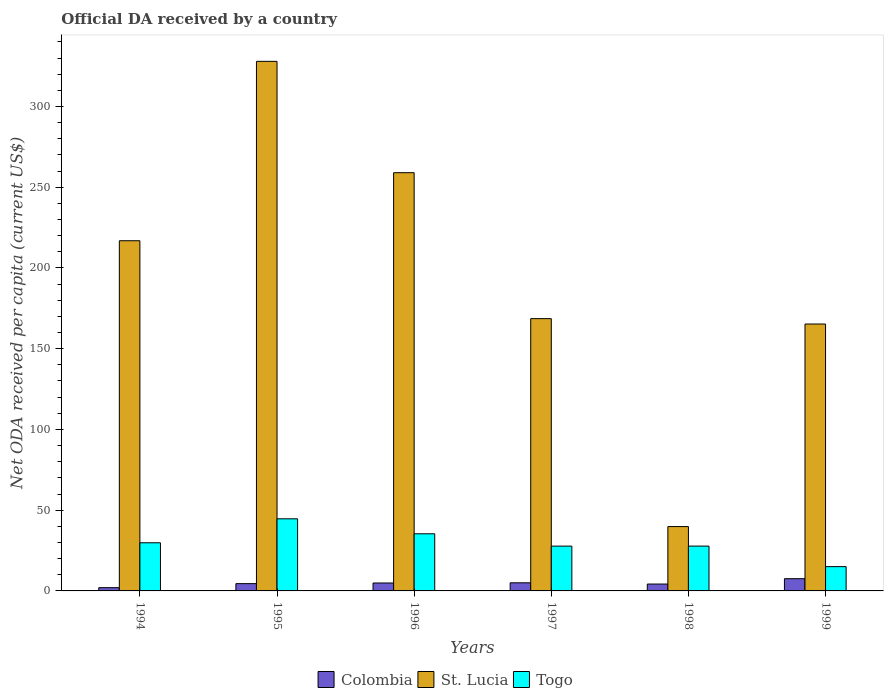Are the number of bars on each tick of the X-axis equal?
Your answer should be very brief. Yes. How many bars are there on the 5th tick from the left?
Your response must be concise. 3. How many bars are there on the 5th tick from the right?
Offer a terse response. 3. In how many cases, is the number of bars for a given year not equal to the number of legend labels?
Offer a very short reply. 0. What is the ODA received in in St. Lucia in 1995?
Your answer should be compact. 327.94. Across all years, what is the maximum ODA received in in Togo?
Give a very brief answer. 44.66. Across all years, what is the minimum ODA received in in Togo?
Ensure brevity in your answer.  15.04. In which year was the ODA received in in St. Lucia minimum?
Your response must be concise. 1998. What is the total ODA received in in St. Lucia in the graph?
Your response must be concise. 1177.52. What is the difference between the ODA received in in St. Lucia in 1994 and that in 1998?
Offer a very short reply. 177. What is the difference between the ODA received in in Colombia in 1997 and the ODA received in in St. Lucia in 1994?
Offer a very short reply. -211.83. What is the average ODA received in in Togo per year?
Provide a short and direct response. 30.06. In the year 1999, what is the difference between the ODA received in in Colombia and ODA received in in Togo?
Your response must be concise. -7.47. In how many years, is the ODA received in in Togo greater than 30 US$?
Keep it short and to the point. 2. What is the ratio of the ODA received in in Togo in 1994 to that in 1998?
Give a very brief answer. 1.07. Is the ODA received in in Colombia in 1996 less than that in 1999?
Ensure brevity in your answer.  Yes. Is the difference between the ODA received in in Colombia in 1995 and 1997 greater than the difference between the ODA received in in Togo in 1995 and 1997?
Keep it short and to the point. No. What is the difference between the highest and the second highest ODA received in in Colombia?
Your answer should be very brief. 2.55. What is the difference between the highest and the lowest ODA received in in Togo?
Your answer should be compact. 29.62. Is the sum of the ODA received in in St. Lucia in 1998 and 1999 greater than the maximum ODA received in in Colombia across all years?
Offer a very short reply. Yes. What does the 2nd bar from the left in 1997 represents?
Your answer should be very brief. St. Lucia. What does the 1st bar from the right in 1995 represents?
Give a very brief answer. Togo. Is it the case that in every year, the sum of the ODA received in in Togo and ODA received in in St. Lucia is greater than the ODA received in in Colombia?
Offer a terse response. Yes. How many years are there in the graph?
Give a very brief answer. 6. Are the values on the major ticks of Y-axis written in scientific E-notation?
Offer a very short reply. No. Does the graph contain grids?
Your answer should be compact. No. Where does the legend appear in the graph?
Provide a short and direct response. Bottom center. What is the title of the graph?
Your answer should be compact. Official DA received by a country. Does "Other small states" appear as one of the legend labels in the graph?
Offer a very short reply. No. What is the label or title of the Y-axis?
Keep it short and to the point. Net ODA received per capita (current US$). What is the Net ODA received per capita (current US$) in Colombia in 1994?
Give a very brief answer. 2.02. What is the Net ODA received per capita (current US$) of St. Lucia in 1994?
Make the answer very short. 216.85. What is the Net ODA received per capita (current US$) of Togo in 1994?
Your answer should be very brief. 29.82. What is the Net ODA received per capita (current US$) of Colombia in 1995?
Keep it short and to the point. 4.51. What is the Net ODA received per capita (current US$) in St. Lucia in 1995?
Provide a short and direct response. 327.94. What is the Net ODA received per capita (current US$) of Togo in 1995?
Provide a succinct answer. 44.66. What is the Net ODA received per capita (current US$) of Colombia in 1996?
Offer a terse response. 4.91. What is the Net ODA received per capita (current US$) of St. Lucia in 1996?
Provide a succinct answer. 258.99. What is the Net ODA received per capita (current US$) of Togo in 1996?
Your response must be concise. 35.37. What is the Net ODA received per capita (current US$) of Colombia in 1997?
Keep it short and to the point. 5.02. What is the Net ODA received per capita (current US$) in St. Lucia in 1997?
Offer a terse response. 168.62. What is the Net ODA received per capita (current US$) of Togo in 1997?
Offer a very short reply. 27.74. What is the Net ODA received per capita (current US$) of Colombia in 1998?
Provide a short and direct response. 4.26. What is the Net ODA received per capita (current US$) in St. Lucia in 1998?
Keep it short and to the point. 39.85. What is the Net ODA received per capita (current US$) of Togo in 1998?
Give a very brief answer. 27.75. What is the Net ODA received per capita (current US$) in Colombia in 1999?
Offer a very short reply. 7.57. What is the Net ODA received per capita (current US$) in St. Lucia in 1999?
Your answer should be compact. 165.28. What is the Net ODA received per capita (current US$) of Togo in 1999?
Keep it short and to the point. 15.04. Across all years, what is the maximum Net ODA received per capita (current US$) in Colombia?
Offer a very short reply. 7.57. Across all years, what is the maximum Net ODA received per capita (current US$) in St. Lucia?
Your answer should be compact. 327.94. Across all years, what is the maximum Net ODA received per capita (current US$) of Togo?
Offer a very short reply. 44.66. Across all years, what is the minimum Net ODA received per capita (current US$) in Colombia?
Make the answer very short. 2.02. Across all years, what is the minimum Net ODA received per capita (current US$) of St. Lucia?
Offer a very short reply. 39.85. Across all years, what is the minimum Net ODA received per capita (current US$) in Togo?
Your answer should be very brief. 15.04. What is the total Net ODA received per capita (current US$) of Colombia in the graph?
Make the answer very short. 28.3. What is the total Net ODA received per capita (current US$) of St. Lucia in the graph?
Make the answer very short. 1177.52. What is the total Net ODA received per capita (current US$) of Togo in the graph?
Provide a short and direct response. 180.39. What is the difference between the Net ODA received per capita (current US$) in Colombia in 1994 and that in 1995?
Your answer should be very brief. -2.49. What is the difference between the Net ODA received per capita (current US$) in St. Lucia in 1994 and that in 1995?
Provide a short and direct response. -111.09. What is the difference between the Net ODA received per capita (current US$) in Togo in 1994 and that in 1995?
Make the answer very short. -14.85. What is the difference between the Net ODA received per capita (current US$) in Colombia in 1994 and that in 1996?
Offer a very short reply. -2.89. What is the difference between the Net ODA received per capita (current US$) of St. Lucia in 1994 and that in 1996?
Offer a very short reply. -42.14. What is the difference between the Net ODA received per capita (current US$) in Togo in 1994 and that in 1996?
Offer a very short reply. -5.56. What is the difference between the Net ODA received per capita (current US$) of Colombia in 1994 and that in 1997?
Give a very brief answer. -3. What is the difference between the Net ODA received per capita (current US$) in St. Lucia in 1994 and that in 1997?
Your answer should be very brief. 48.23. What is the difference between the Net ODA received per capita (current US$) of Togo in 1994 and that in 1997?
Offer a terse response. 2.07. What is the difference between the Net ODA received per capita (current US$) in Colombia in 1994 and that in 1998?
Your response must be concise. -2.24. What is the difference between the Net ODA received per capita (current US$) of St. Lucia in 1994 and that in 1998?
Offer a terse response. 177. What is the difference between the Net ODA received per capita (current US$) in Togo in 1994 and that in 1998?
Ensure brevity in your answer.  2.06. What is the difference between the Net ODA received per capita (current US$) in Colombia in 1994 and that in 1999?
Keep it short and to the point. -5.55. What is the difference between the Net ODA received per capita (current US$) in St. Lucia in 1994 and that in 1999?
Provide a succinct answer. 51.57. What is the difference between the Net ODA received per capita (current US$) of Togo in 1994 and that in 1999?
Give a very brief answer. 14.77. What is the difference between the Net ODA received per capita (current US$) of Colombia in 1995 and that in 1996?
Make the answer very short. -0.4. What is the difference between the Net ODA received per capita (current US$) in St. Lucia in 1995 and that in 1996?
Your response must be concise. 68.95. What is the difference between the Net ODA received per capita (current US$) in Togo in 1995 and that in 1996?
Your response must be concise. 9.29. What is the difference between the Net ODA received per capita (current US$) of Colombia in 1995 and that in 1997?
Keep it short and to the point. -0.51. What is the difference between the Net ODA received per capita (current US$) of St. Lucia in 1995 and that in 1997?
Your response must be concise. 159.32. What is the difference between the Net ODA received per capita (current US$) in Togo in 1995 and that in 1997?
Your response must be concise. 16.92. What is the difference between the Net ODA received per capita (current US$) of Colombia in 1995 and that in 1998?
Offer a terse response. 0.25. What is the difference between the Net ODA received per capita (current US$) in St. Lucia in 1995 and that in 1998?
Provide a succinct answer. 288.09. What is the difference between the Net ODA received per capita (current US$) in Togo in 1995 and that in 1998?
Your answer should be very brief. 16.91. What is the difference between the Net ODA received per capita (current US$) of Colombia in 1995 and that in 1999?
Provide a succinct answer. -3.06. What is the difference between the Net ODA received per capita (current US$) of St. Lucia in 1995 and that in 1999?
Offer a terse response. 162.66. What is the difference between the Net ODA received per capita (current US$) of Togo in 1995 and that in 1999?
Offer a very short reply. 29.62. What is the difference between the Net ODA received per capita (current US$) in Colombia in 1996 and that in 1997?
Ensure brevity in your answer.  -0.11. What is the difference between the Net ODA received per capita (current US$) in St. Lucia in 1996 and that in 1997?
Keep it short and to the point. 90.38. What is the difference between the Net ODA received per capita (current US$) of Togo in 1996 and that in 1997?
Give a very brief answer. 7.63. What is the difference between the Net ODA received per capita (current US$) of Colombia in 1996 and that in 1998?
Make the answer very short. 0.65. What is the difference between the Net ODA received per capita (current US$) of St. Lucia in 1996 and that in 1998?
Give a very brief answer. 219.14. What is the difference between the Net ODA received per capita (current US$) in Togo in 1996 and that in 1998?
Offer a very short reply. 7.62. What is the difference between the Net ODA received per capita (current US$) in Colombia in 1996 and that in 1999?
Provide a succinct answer. -2.66. What is the difference between the Net ODA received per capita (current US$) of St. Lucia in 1996 and that in 1999?
Your answer should be very brief. 93.72. What is the difference between the Net ODA received per capita (current US$) of Togo in 1996 and that in 1999?
Ensure brevity in your answer.  20.33. What is the difference between the Net ODA received per capita (current US$) in Colombia in 1997 and that in 1998?
Offer a terse response. 0.76. What is the difference between the Net ODA received per capita (current US$) in St. Lucia in 1997 and that in 1998?
Ensure brevity in your answer.  128.76. What is the difference between the Net ODA received per capita (current US$) of Togo in 1997 and that in 1998?
Ensure brevity in your answer.  -0.01. What is the difference between the Net ODA received per capita (current US$) of Colombia in 1997 and that in 1999?
Provide a short and direct response. -2.55. What is the difference between the Net ODA received per capita (current US$) in St. Lucia in 1997 and that in 1999?
Your answer should be very brief. 3.34. What is the difference between the Net ODA received per capita (current US$) of Togo in 1997 and that in 1999?
Give a very brief answer. 12.7. What is the difference between the Net ODA received per capita (current US$) in Colombia in 1998 and that in 1999?
Provide a short and direct response. -3.32. What is the difference between the Net ODA received per capita (current US$) in St. Lucia in 1998 and that in 1999?
Offer a very short reply. -125.42. What is the difference between the Net ODA received per capita (current US$) of Togo in 1998 and that in 1999?
Your answer should be compact. 12.71. What is the difference between the Net ODA received per capita (current US$) in Colombia in 1994 and the Net ODA received per capita (current US$) in St. Lucia in 1995?
Keep it short and to the point. -325.92. What is the difference between the Net ODA received per capita (current US$) in Colombia in 1994 and the Net ODA received per capita (current US$) in Togo in 1995?
Keep it short and to the point. -42.64. What is the difference between the Net ODA received per capita (current US$) of St. Lucia in 1994 and the Net ODA received per capita (current US$) of Togo in 1995?
Your answer should be very brief. 172.19. What is the difference between the Net ODA received per capita (current US$) of Colombia in 1994 and the Net ODA received per capita (current US$) of St. Lucia in 1996?
Offer a terse response. -256.97. What is the difference between the Net ODA received per capita (current US$) of Colombia in 1994 and the Net ODA received per capita (current US$) of Togo in 1996?
Offer a terse response. -33.36. What is the difference between the Net ODA received per capita (current US$) in St. Lucia in 1994 and the Net ODA received per capita (current US$) in Togo in 1996?
Your response must be concise. 181.47. What is the difference between the Net ODA received per capita (current US$) of Colombia in 1994 and the Net ODA received per capita (current US$) of St. Lucia in 1997?
Keep it short and to the point. -166.6. What is the difference between the Net ODA received per capita (current US$) of Colombia in 1994 and the Net ODA received per capita (current US$) of Togo in 1997?
Offer a terse response. -25.72. What is the difference between the Net ODA received per capita (current US$) of St. Lucia in 1994 and the Net ODA received per capita (current US$) of Togo in 1997?
Give a very brief answer. 189.11. What is the difference between the Net ODA received per capita (current US$) of Colombia in 1994 and the Net ODA received per capita (current US$) of St. Lucia in 1998?
Provide a short and direct response. -37.83. What is the difference between the Net ODA received per capita (current US$) in Colombia in 1994 and the Net ODA received per capita (current US$) in Togo in 1998?
Your response must be concise. -25.73. What is the difference between the Net ODA received per capita (current US$) of St. Lucia in 1994 and the Net ODA received per capita (current US$) of Togo in 1998?
Ensure brevity in your answer.  189.1. What is the difference between the Net ODA received per capita (current US$) in Colombia in 1994 and the Net ODA received per capita (current US$) in St. Lucia in 1999?
Keep it short and to the point. -163.26. What is the difference between the Net ODA received per capita (current US$) of Colombia in 1994 and the Net ODA received per capita (current US$) of Togo in 1999?
Provide a short and direct response. -13.02. What is the difference between the Net ODA received per capita (current US$) in St. Lucia in 1994 and the Net ODA received per capita (current US$) in Togo in 1999?
Your answer should be compact. 201.81. What is the difference between the Net ODA received per capita (current US$) of Colombia in 1995 and the Net ODA received per capita (current US$) of St. Lucia in 1996?
Offer a very short reply. -254.48. What is the difference between the Net ODA received per capita (current US$) in Colombia in 1995 and the Net ODA received per capita (current US$) in Togo in 1996?
Offer a terse response. -30.86. What is the difference between the Net ODA received per capita (current US$) in St. Lucia in 1995 and the Net ODA received per capita (current US$) in Togo in 1996?
Your answer should be compact. 292.56. What is the difference between the Net ODA received per capita (current US$) of Colombia in 1995 and the Net ODA received per capita (current US$) of St. Lucia in 1997?
Provide a succinct answer. -164.1. What is the difference between the Net ODA received per capita (current US$) of Colombia in 1995 and the Net ODA received per capita (current US$) of Togo in 1997?
Offer a very short reply. -23.23. What is the difference between the Net ODA received per capita (current US$) of St. Lucia in 1995 and the Net ODA received per capita (current US$) of Togo in 1997?
Offer a very short reply. 300.2. What is the difference between the Net ODA received per capita (current US$) of Colombia in 1995 and the Net ODA received per capita (current US$) of St. Lucia in 1998?
Your answer should be compact. -35.34. What is the difference between the Net ODA received per capita (current US$) of Colombia in 1995 and the Net ODA received per capita (current US$) of Togo in 1998?
Offer a terse response. -23.24. What is the difference between the Net ODA received per capita (current US$) in St. Lucia in 1995 and the Net ODA received per capita (current US$) in Togo in 1998?
Your answer should be very brief. 300.19. What is the difference between the Net ODA received per capita (current US$) in Colombia in 1995 and the Net ODA received per capita (current US$) in St. Lucia in 1999?
Your answer should be very brief. -160.77. What is the difference between the Net ODA received per capita (current US$) in Colombia in 1995 and the Net ODA received per capita (current US$) in Togo in 1999?
Your answer should be compact. -10.53. What is the difference between the Net ODA received per capita (current US$) of St. Lucia in 1995 and the Net ODA received per capita (current US$) of Togo in 1999?
Offer a very short reply. 312.89. What is the difference between the Net ODA received per capita (current US$) of Colombia in 1996 and the Net ODA received per capita (current US$) of St. Lucia in 1997?
Ensure brevity in your answer.  -163.7. What is the difference between the Net ODA received per capita (current US$) of Colombia in 1996 and the Net ODA received per capita (current US$) of Togo in 1997?
Provide a succinct answer. -22.83. What is the difference between the Net ODA received per capita (current US$) in St. Lucia in 1996 and the Net ODA received per capita (current US$) in Togo in 1997?
Your response must be concise. 231.25. What is the difference between the Net ODA received per capita (current US$) of Colombia in 1996 and the Net ODA received per capita (current US$) of St. Lucia in 1998?
Give a very brief answer. -34.94. What is the difference between the Net ODA received per capita (current US$) of Colombia in 1996 and the Net ODA received per capita (current US$) of Togo in 1998?
Your answer should be compact. -22.84. What is the difference between the Net ODA received per capita (current US$) of St. Lucia in 1996 and the Net ODA received per capita (current US$) of Togo in 1998?
Ensure brevity in your answer.  231.24. What is the difference between the Net ODA received per capita (current US$) of Colombia in 1996 and the Net ODA received per capita (current US$) of St. Lucia in 1999?
Make the answer very short. -160.37. What is the difference between the Net ODA received per capita (current US$) in Colombia in 1996 and the Net ODA received per capita (current US$) in Togo in 1999?
Give a very brief answer. -10.13. What is the difference between the Net ODA received per capita (current US$) in St. Lucia in 1996 and the Net ODA received per capita (current US$) in Togo in 1999?
Your response must be concise. 243.95. What is the difference between the Net ODA received per capita (current US$) of Colombia in 1997 and the Net ODA received per capita (current US$) of St. Lucia in 1998?
Offer a very short reply. -34.83. What is the difference between the Net ODA received per capita (current US$) of Colombia in 1997 and the Net ODA received per capita (current US$) of Togo in 1998?
Provide a succinct answer. -22.73. What is the difference between the Net ODA received per capita (current US$) in St. Lucia in 1997 and the Net ODA received per capita (current US$) in Togo in 1998?
Provide a short and direct response. 140.86. What is the difference between the Net ODA received per capita (current US$) of Colombia in 1997 and the Net ODA received per capita (current US$) of St. Lucia in 1999?
Keep it short and to the point. -160.25. What is the difference between the Net ODA received per capita (current US$) in Colombia in 1997 and the Net ODA received per capita (current US$) in Togo in 1999?
Your answer should be very brief. -10.02. What is the difference between the Net ODA received per capita (current US$) of St. Lucia in 1997 and the Net ODA received per capita (current US$) of Togo in 1999?
Keep it short and to the point. 153.57. What is the difference between the Net ODA received per capita (current US$) in Colombia in 1998 and the Net ODA received per capita (current US$) in St. Lucia in 1999?
Offer a terse response. -161.02. What is the difference between the Net ODA received per capita (current US$) of Colombia in 1998 and the Net ODA received per capita (current US$) of Togo in 1999?
Keep it short and to the point. -10.78. What is the difference between the Net ODA received per capita (current US$) of St. Lucia in 1998 and the Net ODA received per capita (current US$) of Togo in 1999?
Your response must be concise. 24.81. What is the average Net ODA received per capita (current US$) in Colombia per year?
Give a very brief answer. 4.72. What is the average Net ODA received per capita (current US$) of St. Lucia per year?
Offer a terse response. 196.25. What is the average Net ODA received per capita (current US$) of Togo per year?
Provide a succinct answer. 30.06. In the year 1994, what is the difference between the Net ODA received per capita (current US$) of Colombia and Net ODA received per capita (current US$) of St. Lucia?
Give a very brief answer. -214.83. In the year 1994, what is the difference between the Net ODA received per capita (current US$) of Colombia and Net ODA received per capita (current US$) of Togo?
Offer a terse response. -27.8. In the year 1994, what is the difference between the Net ODA received per capita (current US$) in St. Lucia and Net ODA received per capita (current US$) in Togo?
Your response must be concise. 187.03. In the year 1995, what is the difference between the Net ODA received per capita (current US$) of Colombia and Net ODA received per capita (current US$) of St. Lucia?
Give a very brief answer. -323.43. In the year 1995, what is the difference between the Net ODA received per capita (current US$) of Colombia and Net ODA received per capita (current US$) of Togo?
Your answer should be compact. -40.15. In the year 1995, what is the difference between the Net ODA received per capita (current US$) in St. Lucia and Net ODA received per capita (current US$) in Togo?
Offer a very short reply. 283.28. In the year 1996, what is the difference between the Net ODA received per capita (current US$) of Colombia and Net ODA received per capita (current US$) of St. Lucia?
Provide a short and direct response. -254.08. In the year 1996, what is the difference between the Net ODA received per capita (current US$) in Colombia and Net ODA received per capita (current US$) in Togo?
Provide a succinct answer. -30.46. In the year 1996, what is the difference between the Net ODA received per capita (current US$) in St. Lucia and Net ODA received per capita (current US$) in Togo?
Ensure brevity in your answer.  223.62. In the year 1997, what is the difference between the Net ODA received per capita (current US$) of Colombia and Net ODA received per capita (current US$) of St. Lucia?
Make the answer very short. -163.59. In the year 1997, what is the difference between the Net ODA received per capita (current US$) in Colombia and Net ODA received per capita (current US$) in Togo?
Offer a terse response. -22.72. In the year 1997, what is the difference between the Net ODA received per capita (current US$) of St. Lucia and Net ODA received per capita (current US$) of Togo?
Make the answer very short. 140.87. In the year 1998, what is the difference between the Net ODA received per capita (current US$) in Colombia and Net ODA received per capita (current US$) in St. Lucia?
Provide a short and direct response. -35.59. In the year 1998, what is the difference between the Net ODA received per capita (current US$) in Colombia and Net ODA received per capita (current US$) in Togo?
Ensure brevity in your answer.  -23.49. In the year 1998, what is the difference between the Net ODA received per capita (current US$) in St. Lucia and Net ODA received per capita (current US$) in Togo?
Give a very brief answer. 12.1. In the year 1999, what is the difference between the Net ODA received per capita (current US$) of Colombia and Net ODA received per capita (current US$) of St. Lucia?
Offer a very short reply. -157.7. In the year 1999, what is the difference between the Net ODA received per capita (current US$) of Colombia and Net ODA received per capita (current US$) of Togo?
Your answer should be very brief. -7.47. In the year 1999, what is the difference between the Net ODA received per capita (current US$) in St. Lucia and Net ODA received per capita (current US$) in Togo?
Provide a short and direct response. 150.23. What is the ratio of the Net ODA received per capita (current US$) in Colombia in 1994 to that in 1995?
Provide a short and direct response. 0.45. What is the ratio of the Net ODA received per capita (current US$) in St. Lucia in 1994 to that in 1995?
Your response must be concise. 0.66. What is the ratio of the Net ODA received per capita (current US$) of Togo in 1994 to that in 1995?
Your answer should be very brief. 0.67. What is the ratio of the Net ODA received per capita (current US$) of Colombia in 1994 to that in 1996?
Provide a short and direct response. 0.41. What is the ratio of the Net ODA received per capita (current US$) of St. Lucia in 1994 to that in 1996?
Offer a terse response. 0.84. What is the ratio of the Net ODA received per capita (current US$) of Togo in 1994 to that in 1996?
Provide a short and direct response. 0.84. What is the ratio of the Net ODA received per capita (current US$) of Colombia in 1994 to that in 1997?
Offer a very short reply. 0.4. What is the ratio of the Net ODA received per capita (current US$) in St. Lucia in 1994 to that in 1997?
Make the answer very short. 1.29. What is the ratio of the Net ODA received per capita (current US$) of Togo in 1994 to that in 1997?
Ensure brevity in your answer.  1.07. What is the ratio of the Net ODA received per capita (current US$) of Colombia in 1994 to that in 1998?
Keep it short and to the point. 0.47. What is the ratio of the Net ODA received per capita (current US$) in St. Lucia in 1994 to that in 1998?
Your answer should be compact. 5.44. What is the ratio of the Net ODA received per capita (current US$) in Togo in 1994 to that in 1998?
Ensure brevity in your answer.  1.07. What is the ratio of the Net ODA received per capita (current US$) in Colombia in 1994 to that in 1999?
Provide a succinct answer. 0.27. What is the ratio of the Net ODA received per capita (current US$) of St. Lucia in 1994 to that in 1999?
Your answer should be very brief. 1.31. What is the ratio of the Net ODA received per capita (current US$) in Togo in 1994 to that in 1999?
Offer a terse response. 1.98. What is the ratio of the Net ODA received per capita (current US$) of Colombia in 1995 to that in 1996?
Provide a short and direct response. 0.92. What is the ratio of the Net ODA received per capita (current US$) in St. Lucia in 1995 to that in 1996?
Offer a very short reply. 1.27. What is the ratio of the Net ODA received per capita (current US$) of Togo in 1995 to that in 1996?
Your response must be concise. 1.26. What is the ratio of the Net ODA received per capita (current US$) in Colombia in 1995 to that in 1997?
Provide a short and direct response. 0.9. What is the ratio of the Net ODA received per capita (current US$) of St. Lucia in 1995 to that in 1997?
Offer a very short reply. 1.94. What is the ratio of the Net ODA received per capita (current US$) of Togo in 1995 to that in 1997?
Your answer should be very brief. 1.61. What is the ratio of the Net ODA received per capita (current US$) of Colombia in 1995 to that in 1998?
Your response must be concise. 1.06. What is the ratio of the Net ODA received per capita (current US$) of St. Lucia in 1995 to that in 1998?
Your answer should be compact. 8.23. What is the ratio of the Net ODA received per capita (current US$) of Togo in 1995 to that in 1998?
Provide a short and direct response. 1.61. What is the ratio of the Net ODA received per capita (current US$) of Colombia in 1995 to that in 1999?
Your answer should be compact. 0.6. What is the ratio of the Net ODA received per capita (current US$) in St. Lucia in 1995 to that in 1999?
Offer a terse response. 1.98. What is the ratio of the Net ODA received per capita (current US$) of Togo in 1995 to that in 1999?
Make the answer very short. 2.97. What is the ratio of the Net ODA received per capita (current US$) in Colombia in 1996 to that in 1997?
Keep it short and to the point. 0.98. What is the ratio of the Net ODA received per capita (current US$) in St. Lucia in 1996 to that in 1997?
Your answer should be compact. 1.54. What is the ratio of the Net ODA received per capita (current US$) in Togo in 1996 to that in 1997?
Your response must be concise. 1.28. What is the ratio of the Net ODA received per capita (current US$) of Colombia in 1996 to that in 1998?
Offer a terse response. 1.15. What is the ratio of the Net ODA received per capita (current US$) in St. Lucia in 1996 to that in 1998?
Offer a very short reply. 6.5. What is the ratio of the Net ODA received per capita (current US$) in Togo in 1996 to that in 1998?
Your answer should be very brief. 1.27. What is the ratio of the Net ODA received per capita (current US$) of Colombia in 1996 to that in 1999?
Give a very brief answer. 0.65. What is the ratio of the Net ODA received per capita (current US$) of St. Lucia in 1996 to that in 1999?
Your response must be concise. 1.57. What is the ratio of the Net ODA received per capita (current US$) in Togo in 1996 to that in 1999?
Offer a terse response. 2.35. What is the ratio of the Net ODA received per capita (current US$) of Colombia in 1997 to that in 1998?
Provide a short and direct response. 1.18. What is the ratio of the Net ODA received per capita (current US$) of St. Lucia in 1997 to that in 1998?
Offer a very short reply. 4.23. What is the ratio of the Net ODA received per capita (current US$) of Togo in 1997 to that in 1998?
Offer a terse response. 1. What is the ratio of the Net ODA received per capita (current US$) of Colombia in 1997 to that in 1999?
Keep it short and to the point. 0.66. What is the ratio of the Net ODA received per capita (current US$) of St. Lucia in 1997 to that in 1999?
Keep it short and to the point. 1.02. What is the ratio of the Net ODA received per capita (current US$) of Togo in 1997 to that in 1999?
Offer a very short reply. 1.84. What is the ratio of the Net ODA received per capita (current US$) of Colombia in 1998 to that in 1999?
Offer a very short reply. 0.56. What is the ratio of the Net ODA received per capita (current US$) of St. Lucia in 1998 to that in 1999?
Your response must be concise. 0.24. What is the ratio of the Net ODA received per capita (current US$) in Togo in 1998 to that in 1999?
Provide a short and direct response. 1.84. What is the difference between the highest and the second highest Net ODA received per capita (current US$) of Colombia?
Offer a terse response. 2.55. What is the difference between the highest and the second highest Net ODA received per capita (current US$) in St. Lucia?
Give a very brief answer. 68.95. What is the difference between the highest and the second highest Net ODA received per capita (current US$) in Togo?
Give a very brief answer. 9.29. What is the difference between the highest and the lowest Net ODA received per capita (current US$) in Colombia?
Give a very brief answer. 5.55. What is the difference between the highest and the lowest Net ODA received per capita (current US$) of St. Lucia?
Your answer should be compact. 288.09. What is the difference between the highest and the lowest Net ODA received per capita (current US$) in Togo?
Keep it short and to the point. 29.62. 